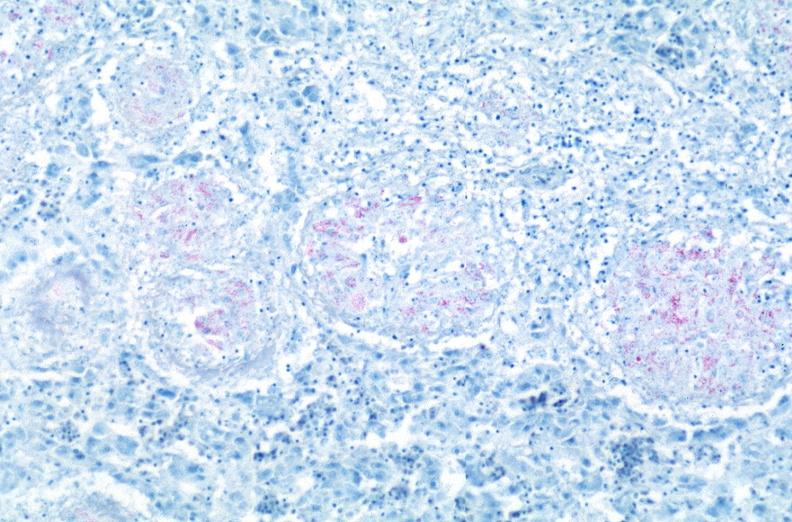s section of spleen through hilum present?
Answer the question using a single word or phrase. No 